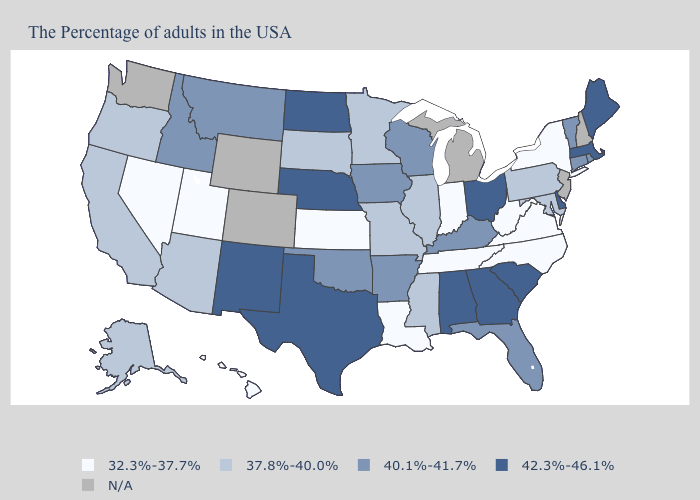What is the value of South Dakota?
Give a very brief answer. 37.8%-40.0%. Name the states that have a value in the range 42.3%-46.1%?
Be succinct. Maine, Massachusetts, Delaware, South Carolina, Ohio, Georgia, Alabama, Nebraska, Texas, North Dakota, New Mexico. What is the value of Florida?
Answer briefly. 40.1%-41.7%. Name the states that have a value in the range 32.3%-37.7%?
Quick response, please. New York, Virginia, North Carolina, West Virginia, Indiana, Tennessee, Louisiana, Kansas, Utah, Nevada, Hawaii. What is the value of Hawaii?
Short answer required. 32.3%-37.7%. Does the map have missing data?
Be succinct. Yes. Does Nevada have the lowest value in the USA?
Be succinct. Yes. Among the states that border West Virginia , does Maryland have the lowest value?
Be succinct. No. Which states have the lowest value in the South?
Keep it brief. Virginia, North Carolina, West Virginia, Tennessee, Louisiana. Among the states that border Georgia , does South Carolina have the highest value?
Write a very short answer. Yes. Name the states that have a value in the range 32.3%-37.7%?
Keep it brief. New York, Virginia, North Carolina, West Virginia, Indiana, Tennessee, Louisiana, Kansas, Utah, Nevada, Hawaii. What is the lowest value in the USA?
Write a very short answer. 32.3%-37.7%. What is the lowest value in the USA?
Keep it brief. 32.3%-37.7%. Is the legend a continuous bar?
Short answer required. No. What is the value of South Dakota?
Quick response, please. 37.8%-40.0%. 